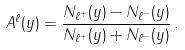Convert formula to latex. <formula><loc_0><loc_0><loc_500><loc_500>A ^ { \ell } ( y ) = \frac { N _ { \ell ^ { + } } ( y ) - N _ { \ell ^ { - } } ( y ) } { N _ { \ell ^ { + } } ( y ) + N _ { \ell ^ { - } } ( y ) } \, .</formula> 